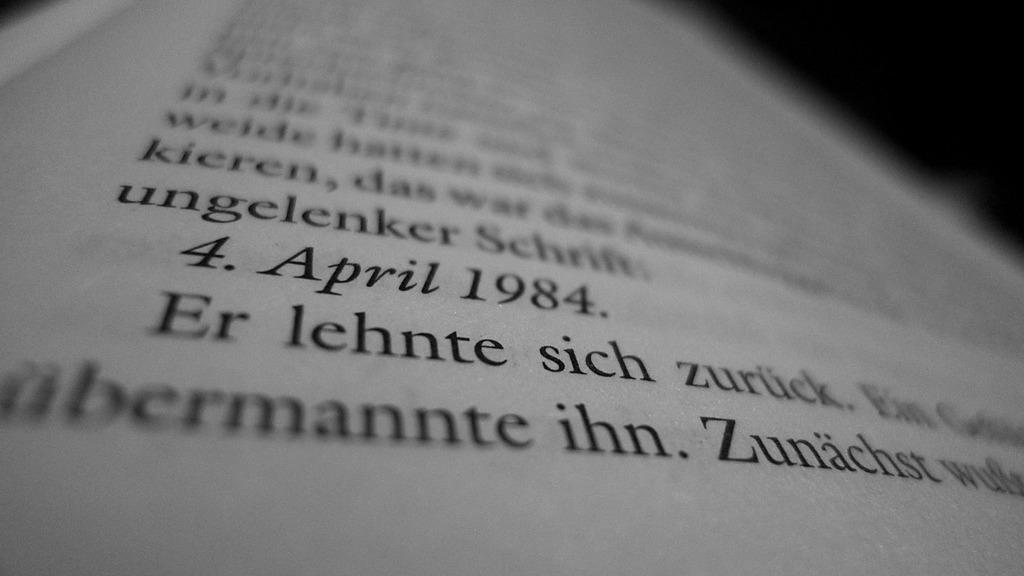<image>
Create a compact narrative representing the image presented. A page of a book with 4. April 1984 shown prominently. 